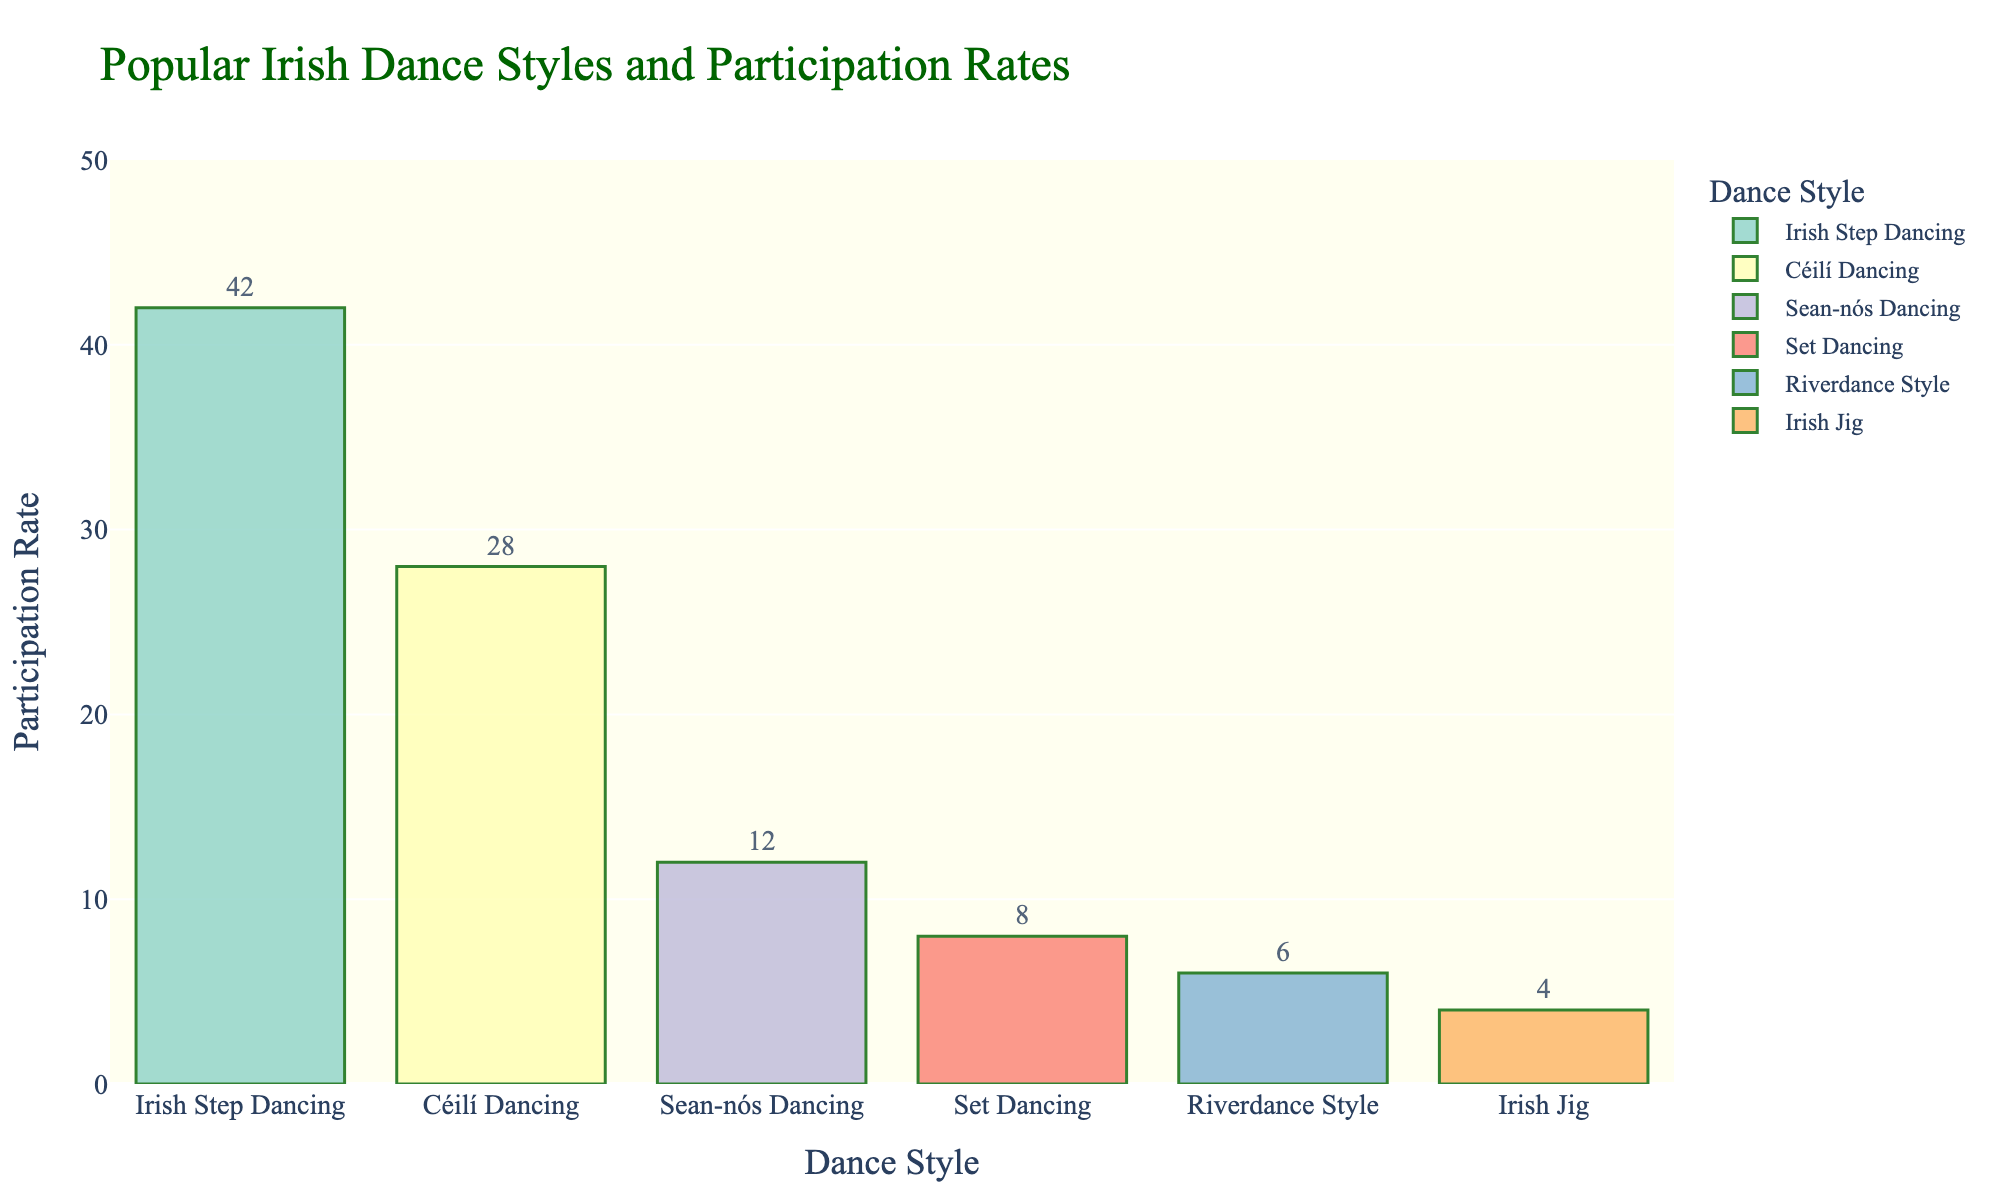What dance style has the highest participation rate? The bar representing Irish Step Dancing is the tallest among all, meaning it has the highest participation rate.
Answer: Irish Step Dancing Which two dance styles have the closest participation rates? We can see that the bars for Irish Jig and Riverdance Style are very close in height. Their participation rates are 4% and 6%, respectively.
Answer: Irish Jig and Riverdance Style What is the total participation rate of all dance styles combined? Add the participation rates of all dance styles: 42 + 28 + 12 + 8 + 6 + 4 = 100
Answer: 100% How much higher is the participation rate of Céilí Dancing compared to Riverdance Style? Subtract the participation rate of Riverdance Style from that of Céilí Dancing: 28 - 6 = 22
Answer: 22% Which dance style has the lowest participation rate? The bar for Irish Jig is the shortest among all, indicating it has the lowest participation rate of 4%.
Answer: Irish Jig What is the average participation rate of the top three dance styles? The top three dance styles are Irish Step Dancing, Céilí Dancing, and Sean-nós Dancing. Their participation rates are 42, 28, and 12. Average = (42 + 28 + 12) / 3 = 82 / 3 ≈ 27.33
Answer: ≈ 27.33 Is the participation rate of Sean-nós Dancing greater than the combined participation rates of Set Dancing and Irish Jig? First, find the combined participation rates of Set Dancing and Irish Jig, which is 8 + 4 = 12. Sean-nós Dancing has a participation rate of 12, which is equal to that combined total.
Answer: No How many percentages higher is the participation rate of the most popular dance style compared to the least popular one? Subtract the participation rate of the least popular dance style (Irish Jig, 4%) from the most popular one (Irish Step Dancing, 42%): 42 - 4 = 38
Answer: 38 Among the dance styles, which one has a participation rate that is exactly double that of another style? The participation rate of Set Dancing (8%) is exactly double that of Irish Jig (4%).
Answer: Set Dancing and Irish Jig 